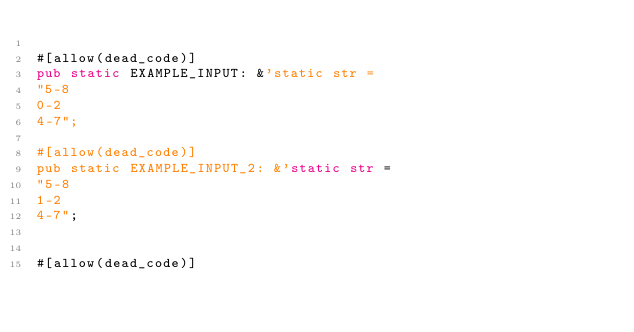<code> <loc_0><loc_0><loc_500><loc_500><_Rust_>
#[allow(dead_code)]
pub static EXAMPLE_INPUT: &'static str =
"5-8
0-2
4-7";

#[allow(dead_code)]
pub static EXAMPLE_INPUT_2: &'static str =
"5-8
1-2
4-7";


#[allow(dead_code)]</code> 